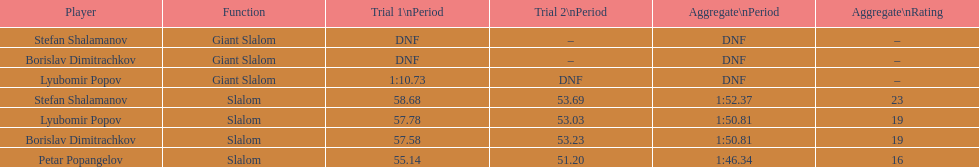Who was last in the slalom overall? Stefan Shalamanov. 